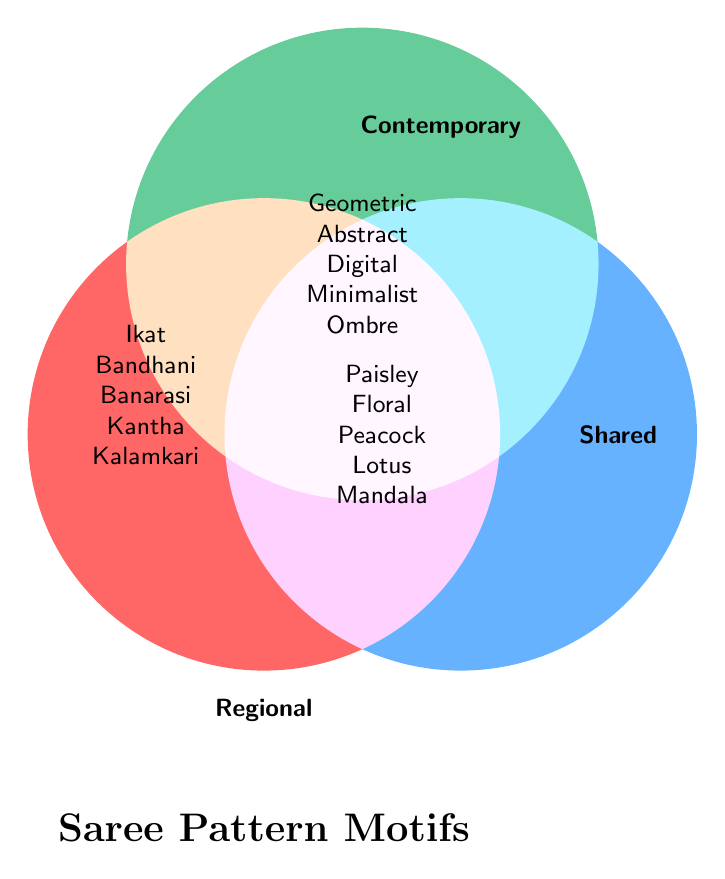What are the shared motifs between regional and contemporary saree patterns? The shared motifs are those design elements in the overlapping sections of the Venn Diagram.
Answer: Paisley, Floral motifs, Peacock designs, Lotus designs, Mandala patterns Which motifs are unique to regional patterns only? Regional-only motifs are found in the section that signifies regional patterns without overlap.
Answer: Ikat, Bandhani, Banarasi brocade, Kantha embroidery, Kalamkari How many contemporary patterns are shared with regional patterns? Count the motifs in the shared section that overlap with contemporary motifs.
Answer: Five Compare the number of unique motifs in regional and contemporary patterns. Count the number of unique motifs in each category and compare: Regional (Ikat, Bandhani, Banarasi, Kantha, Kalamkari) vs. Contemporary (Geometric prints, Abstract art, Digital prints, Minimalist patterns, Ombre effects).
Answer: Equal Which motif is shared across all the patterns shown? Identify motifs present in both regional and contemporary categories in the shared section.
Answer: None What are the associative patterns connected through 'Floral motifs'? Look at both categories to see which patterns are connected by 'Floral motifs' in the shared section.
Answer: Bandhani (Regional), Abstract art (Contemporary) How many motifs are present in each section (Regional, Contemporary, Shared)? Count motifs in each section of the Venn Diagram. Regional: 5, Contemporary: 5, Shared: 5
Answer: 5 in each 